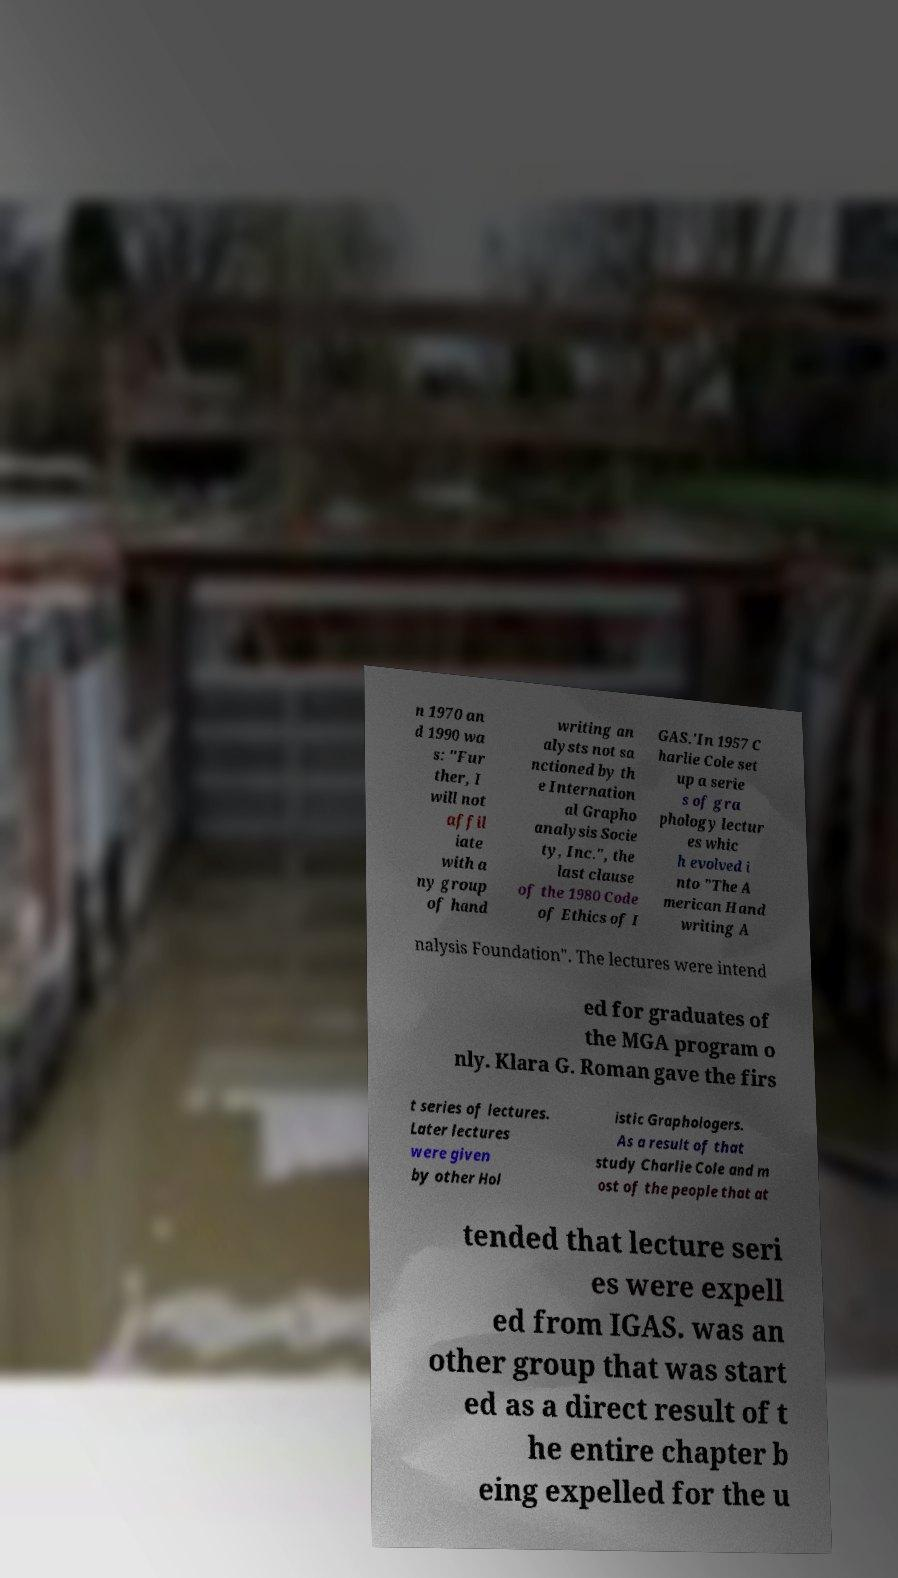There's text embedded in this image that I need extracted. Can you transcribe it verbatim? n 1970 an d 1990 wa s: "Fur ther, I will not affil iate with a ny group of hand writing an alysts not sa nctioned by th e Internation al Grapho analysis Socie ty, Inc.", the last clause of the 1980 Code of Ethics of I GAS.'In 1957 C harlie Cole set up a serie s of gra phology lectur es whic h evolved i nto "The A merican Hand writing A nalysis Foundation". The lectures were intend ed for graduates of the MGA program o nly. Klara G. Roman gave the firs t series of lectures. Later lectures were given by other Hol istic Graphologers. As a result of that study Charlie Cole and m ost of the people that at tended that lecture seri es were expell ed from IGAS. was an other group that was start ed as a direct result of t he entire chapter b eing expelled for the u 